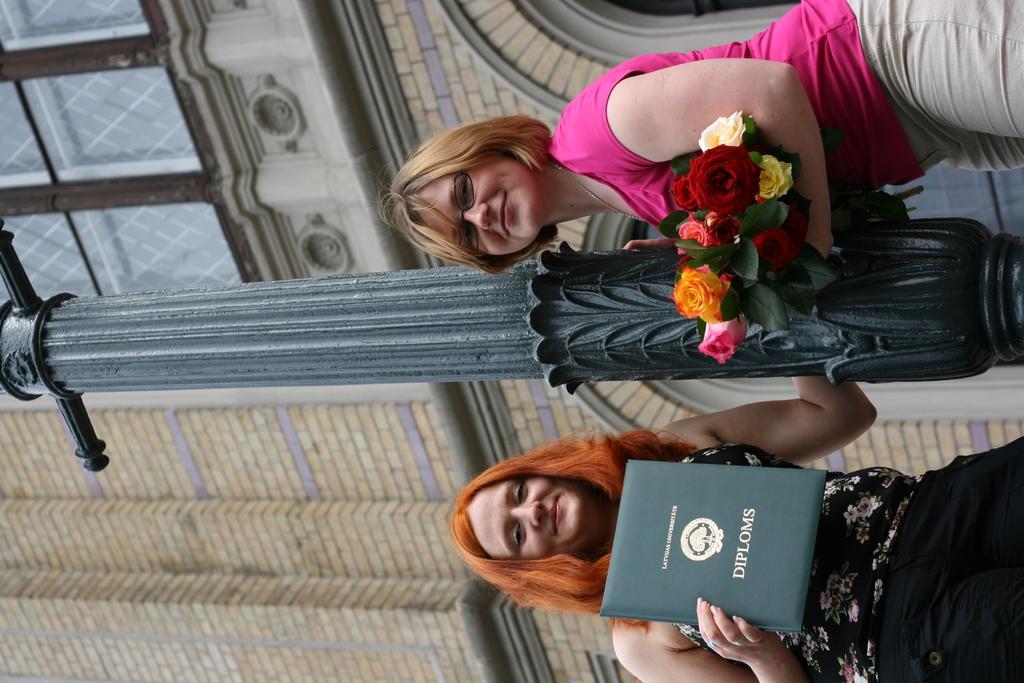How would you summarize this image in a sentence or two? In this picture we can see two women, they are standing beside the pole and they both are smiling, the left side woman is holding a book and the right side woman is holding flowers, in the background we can see a building. 